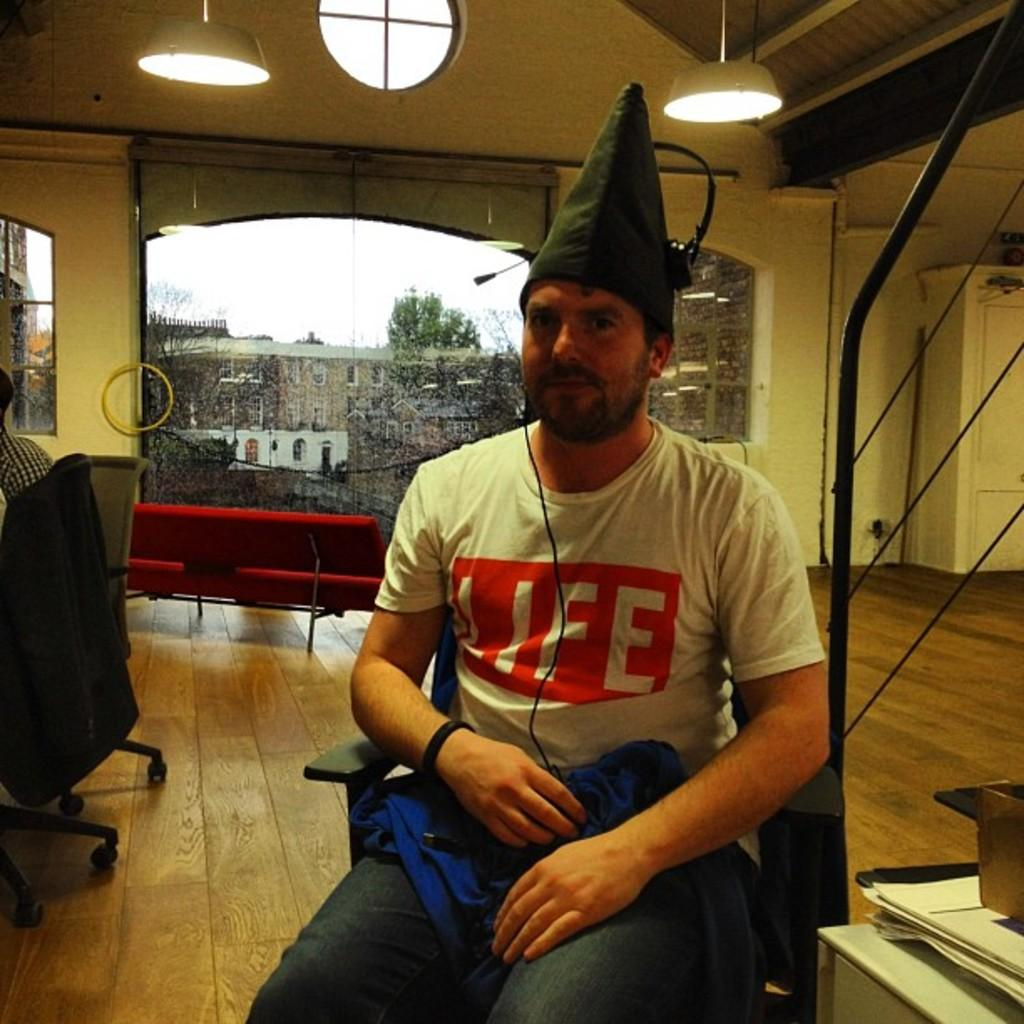What is the man in the image doing? The man is sitting on a chair in the image. How many chairs are visible in the image? There are two chairs in the background of the image, in addition to the chair the man is sitting on. What can be seen on the ceiling in the image? There are lights on the ceiling in the image. What is visible outside the windows in the image? Buildings are visible through the windows in the image. How many geese are flying through the cable in the image? There are no geese or cables present in the image. 